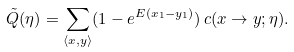Convert formula to latex. <formula><loc_0><loc_0><loc_500><loc_500>\tilde { Q } ( \eta ) = \sum _ { \langle x , y \rangle } ( 1 - e ^ { E ( x _ { 1 } - y _ { 1 } ) } ) \, c ( x \to y ; \eta ) .</formula> 